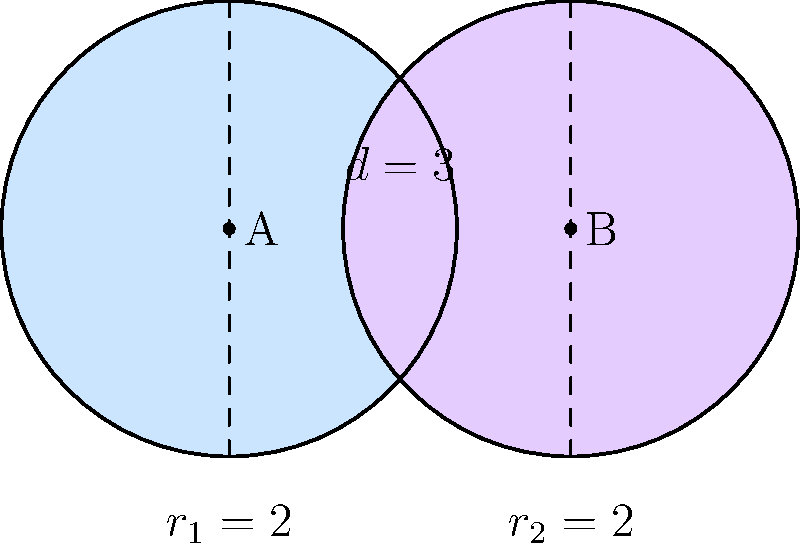In a multi-well plate, two circular cell cultures A and B are partially overlapping. Both cultures have a radius of 2 mm, and their centers are 3 mm apart. Calculate the area of the overlapping region where the two cell cultures intersect. Round your answer to two decimal places. To calculate the area of overlap between two circles, we can use the formula:

$$A = 2r^2 \arccos(\frac{d}{2r}) - d\sqrt{r^2 - (\frac{d}{2})^2}$$

Where:
$A$ is the area of overlap
$r$ is the radius of both circles
$d$ is the distance between the centers

Given:
$r_1 = r_2 = 2$ mm
$d = 3$ mm

Step 1: Substitute the values into the formula:
$$A = 2(2^2) \arccos(\frac{3}{2(2)}) - 3\sqrt{2^2 - (\frac{3}{2})^2}$$

Step 2: Simplify:
$$A = 8 \arccos(\frac{3}{4}) - 3\sqrt{4 - \frac{9}{4}}$$
$$A = 8 \arccos(0.75) - 3\sqrt{\frac{7}{4}}$$

Step 3: Calculate:
$$A = 8(0.7227) - 3(1.3229)$$
$$A = 5.7816 - 3.9687$$
$$A = 1.8129$$

Step 4: Round to two decimal places:
$$A ≈ 1.81 \text{ mm}^2$$
Answer: $1.81 \text{ mm}^2$ 